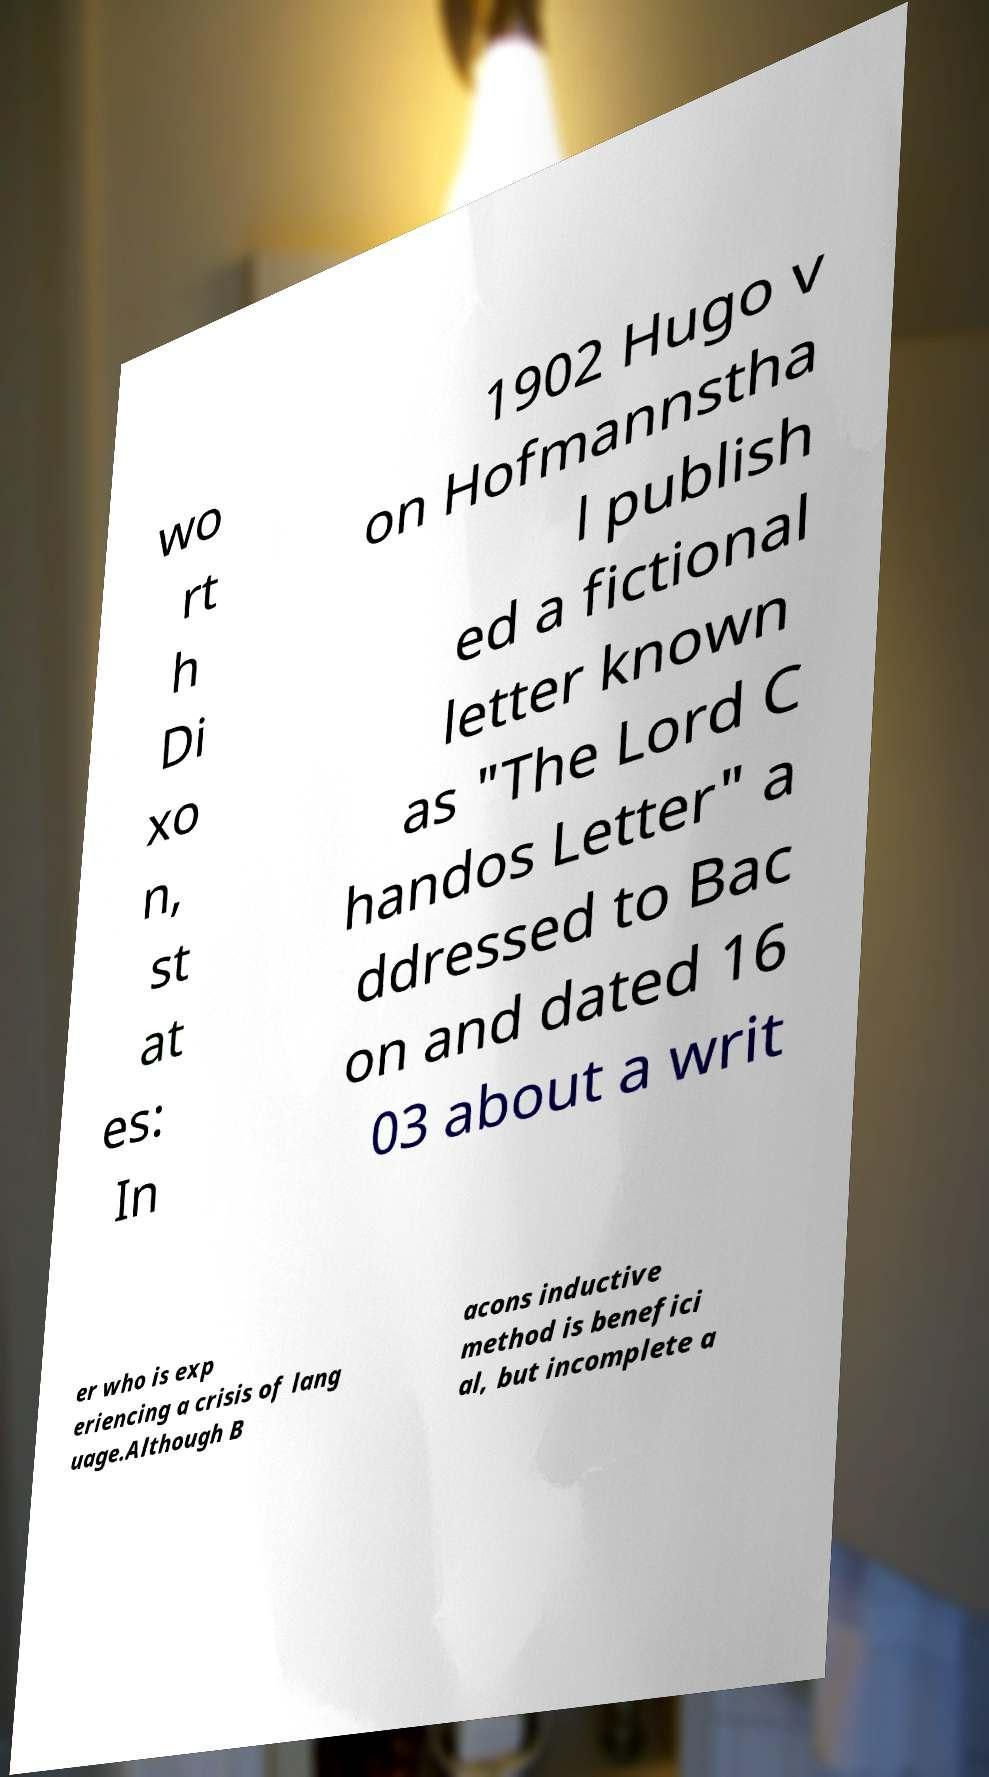Could you extract and type out the text from this image? wo rt h Di xo n, st at es: In 1902 Hugo v on Hofmannstha l publish ed a fictional letter known as "The Lord C handos Letter" a ddressed to Bac on and dated 16 03 about a writ er who is exp eriencing a crisis of lang uage.Although B acons inductive method is benefici al, but incomplete a 